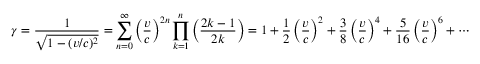Convert formula to latex. <formula><loc_0><loc_0><loc_500><loc_500>\gamma = { \frac { 1 } { \sqrt { 1 - ( v / c ) ^ { 2 } } } } = \sum _ { n = 0 } ^ { \infty } \left ( { \frac { v } { c } } \right ) ^ { 2 n } \prod _ { k = 1 } ^ { n } \left ( { \frac { 2 k - 1 } { 2 k } } \right ) = 1 + { \frac { 1 } { 2 } } \left ( { \frac { v } { c } } \right ) ^ { 2 } + { \frac { 3 } { 8 } } \left ( { \frac { v } { c } } \right ) ^ { 4 } + { \frac { 5 } { 1 6 } } \left ( { \frac { v } { c } } \right ) ^ { 6 } + \cdots</formula> 